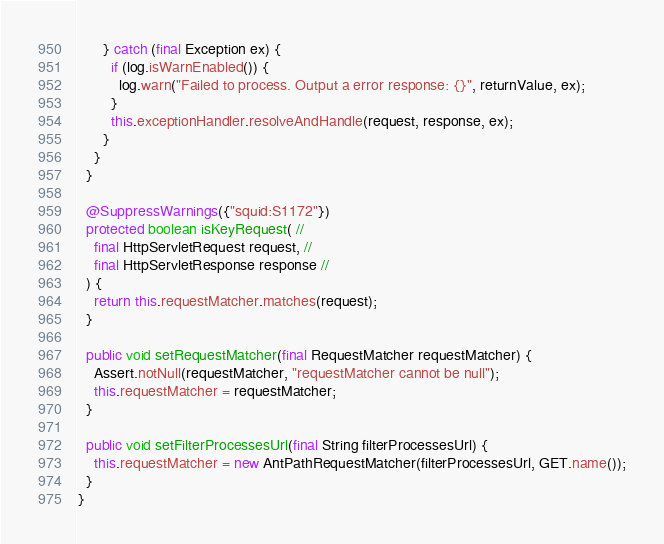Convert code to text. <code><loc_0><loc_0><loc_500><loc_500><_Java_>      } catch (final Exception ex) {
        if (log.isWarnEnabled()) {
          log.warn("Failed to process. Output a error response: {}", returnValue, ex);
        }
        this.exceptionHandler.resolveAndHandle(request, response, ex);
      }
    }
  }

  @SuppressWarnings({"squid:S1172"})
  protected boolean isKeyRequest( //
    final HttpServletRequest request, //
    final HttpServletResponse response //
  ) {
    return this.requestMatcher.matches(request);
  }

  public void setRequestMatcher(final RequestMatcher requestMatcher) {
    Assert.notNull(requestMatcher, "requestMatcher cannot be null");
    this.requestMatcher = requestMatcher;
  }

  public void setFilterProcessesUrl(final String filterProcessesUrl) {
    this.requestMatcher = new AntPathRequestMatcher(filterProcessesUrl, GET.name());
  }
}
</code> 